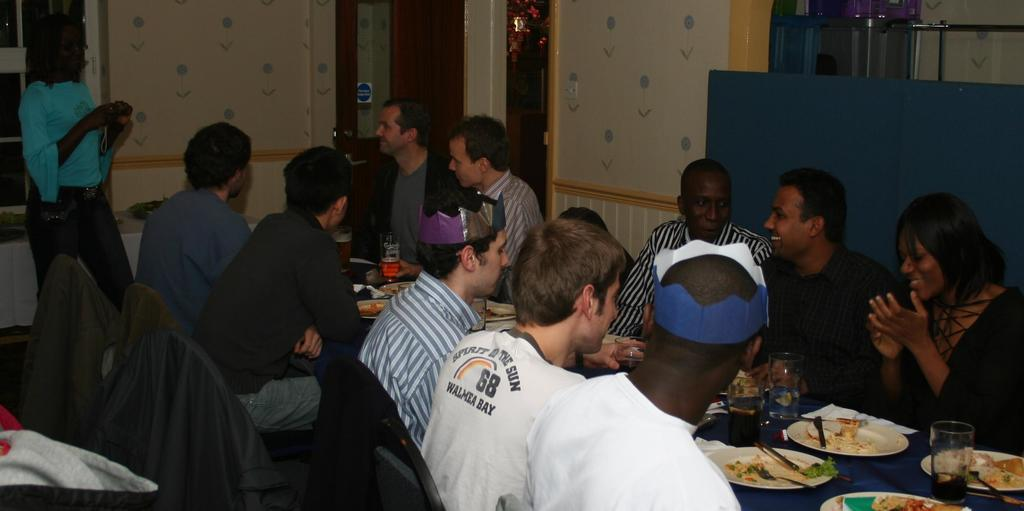Provide a one-sentence caption for the provided image. A man in a white shirt with the number 68. 